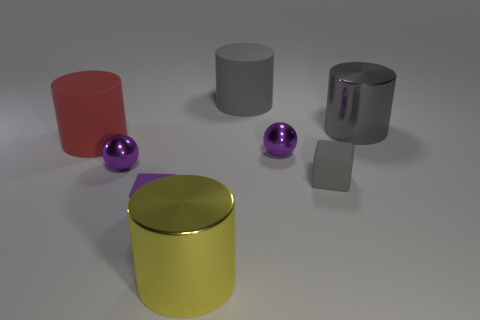Subtract all big gray metal cylinders. How many cylinders are left? 3 Subtract all purple blocks. How many blocks are left? 1 Subtract all red cubes. How many gray cylinders are left? 2 Add 1 big cylinders. How many objects exist? 9 Subtract 1 balls. How many balls are left? 1 Subtract all spheres. How many objects are left? 6 Subtract all gray blocks. Subtract all gray cylinders. How many blocks are left? 1 Subtract all big green matte cylinders. Subtract all large gray objects. How many objects are left? 6 Add 5 tiny purple objects. How many tiny purple objects are left? 8 Add 1 large brown metallic things. How many large brown metallic things exist? 1 